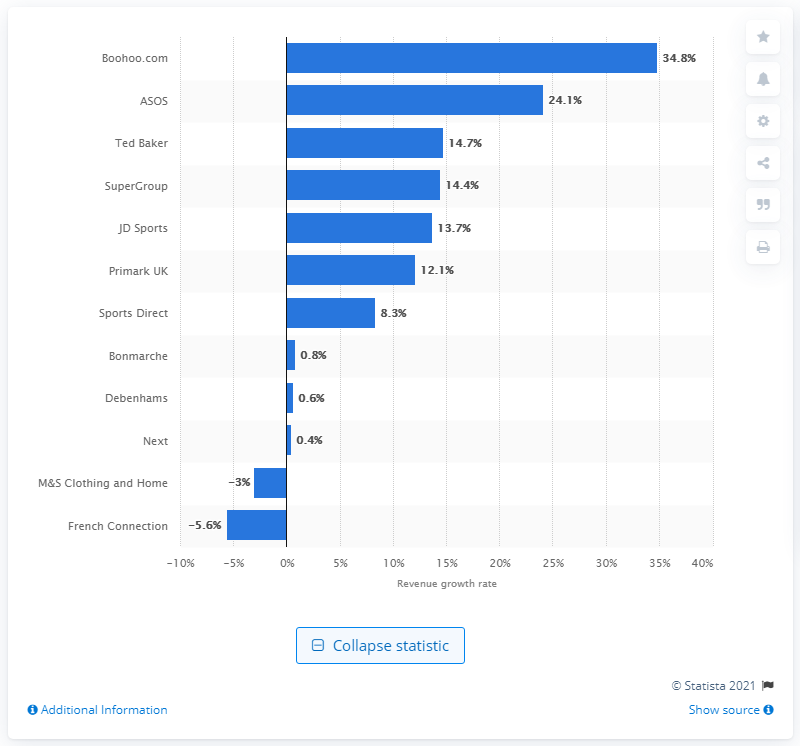Point out several critical features in this image. Boohoo.com is followed by ASOS, a leading online fashion retailer. 